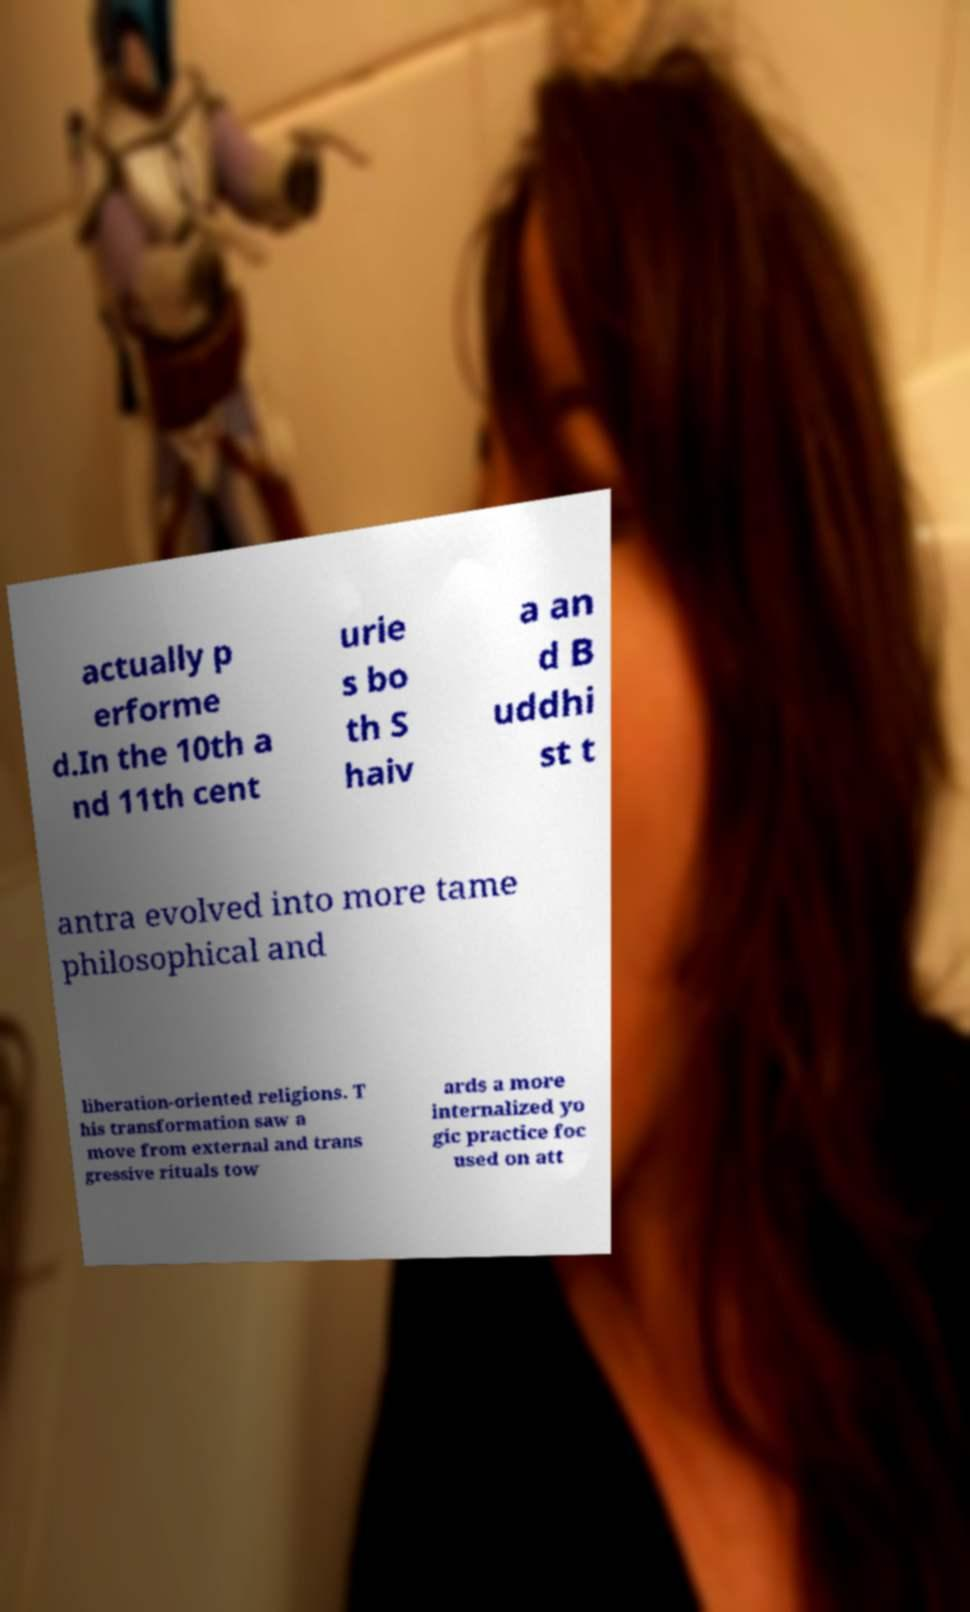I need the written content from this picture converted into text. Can you do that? actually p erforme d.In the 10th a nd 11th cent urie s bo th S haiv a an d B uddhi st t antra evolved into more tame philosophical and liberation-oriented religions. T his transformation saw a move from external and trans gressive rituals tow ards a more internalized yo gic practice foc used on att 